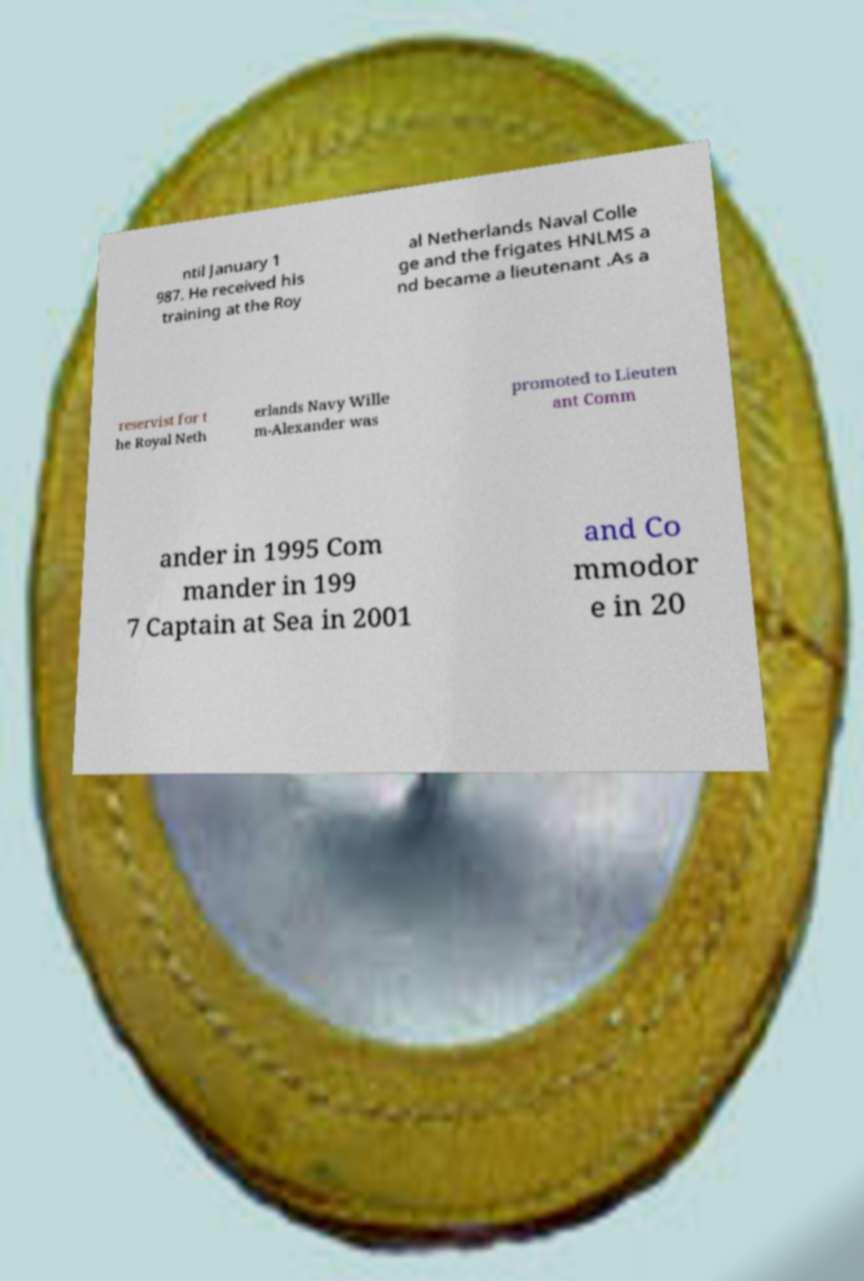Can you read and provide the text displayed in the image?This photo seems to have some interesting text. Can you extract and type it out for me? ntil January 1 987. He received his training at the Roy al Netherlands Naval Colle ge and the frigates HNLMS a nd became a lieutenant .As a reservist for t he Royal Neth erlands Navy Wille m-Alexander was promoted to Lieuten ant Comm ander in 1995 Com mander in 199 7 Captain at Sea in 2001 and Co mmodor e in 20 